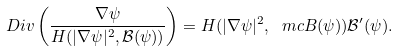<formula> <loc_0><loc_0><loc_500><loc_500>\ D i v \left ( \frac { \nabla \psi } { H ( | \nabla \psi | ^ { 2 } , \mathcal { B } ( \psi ) ) } \right ) = H ( | \nabla \psi | ^ { 2 } , \ m c B ( \psi ) ) \mathcal { B } ^ { \prime } ( \psi ) .</formula> 